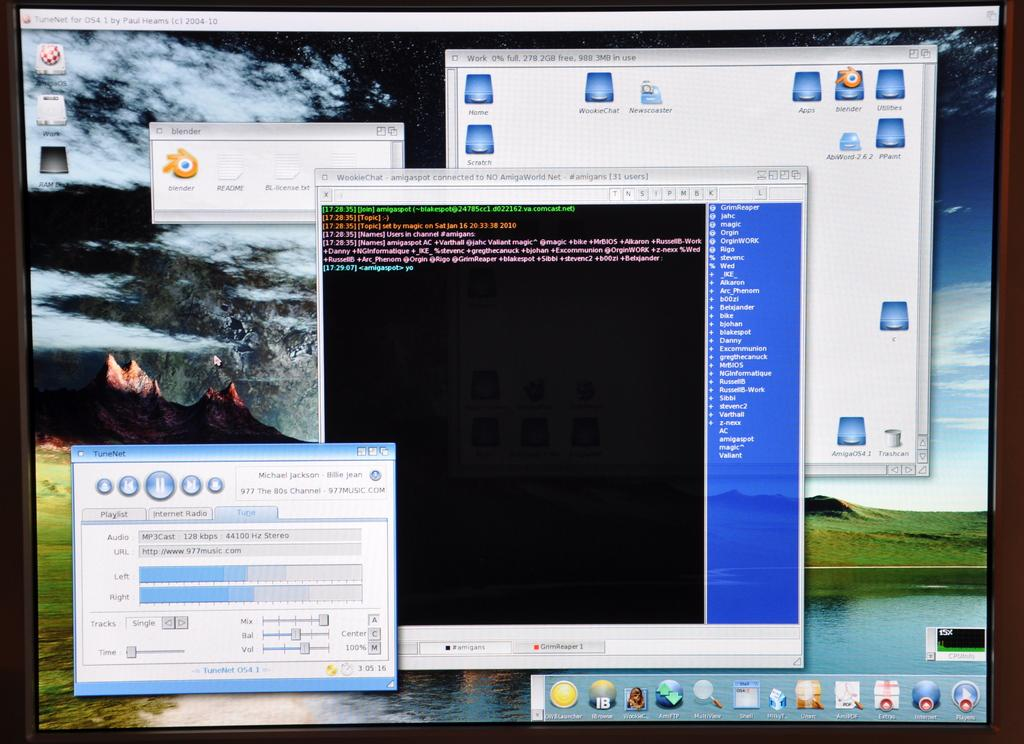<image>
Write a terse but informative summary of the picture. A computer monitor shows several open windows including TuneNet which is playing Billie Jean by Michael Jackson. 